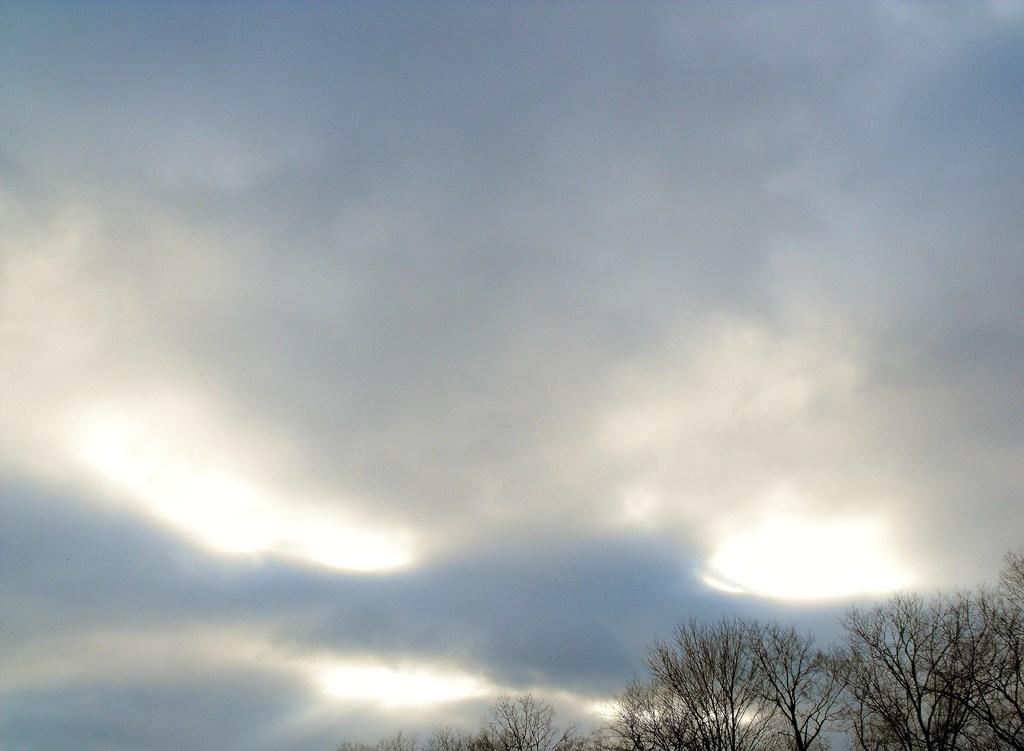What can be seen in the background of the image? The sky is visible in the image. What is present in the sky in the image? There are clouds in the image. What type of vegetation can be seen in the image? There are trees in the image. How many oranges are hanging from the trees in the image? There are no oranges present in the image; it only features trees. What type of zephyr can be seen blowing through the trees in the image? There is no zephyr present in the image, and the concept of a zephyr is not applicable to this context. 